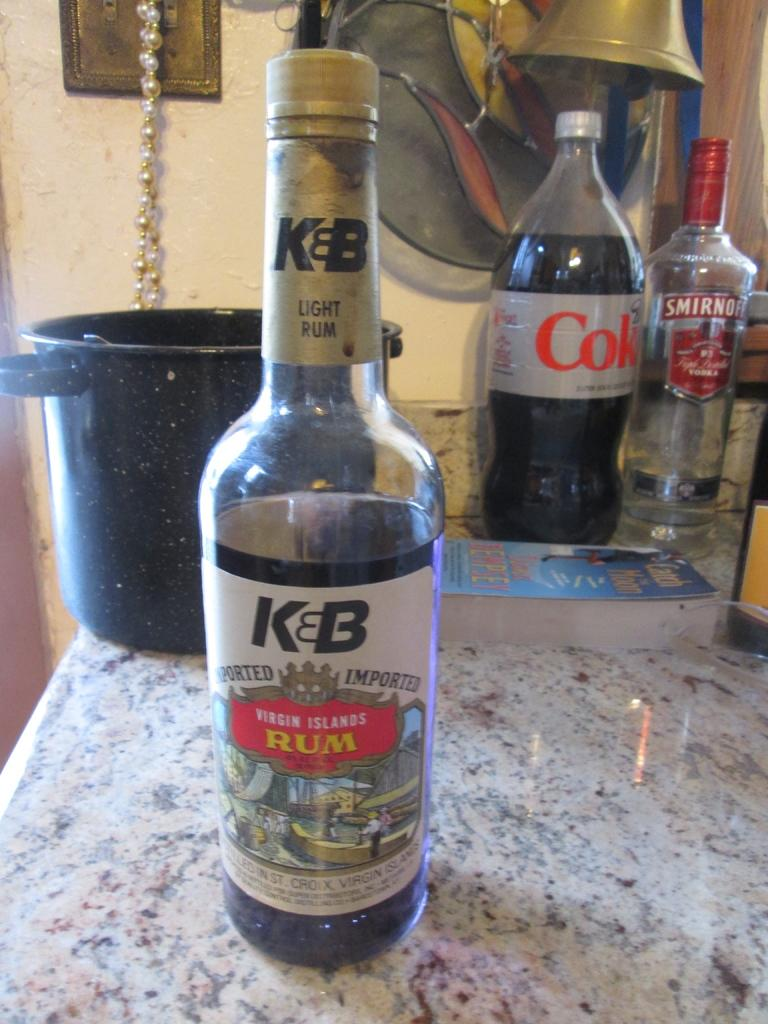What object can be seen in the image that typically contains a liquid? There is a bottle in the image that typically contains a liquid. What object can be seen in the image that is used for holding or reading information? There is a book in the image that is used for holding or reading information. What object can be seen in the image that helps us understand the context of the image? There is a bowl in the image, which could suggest that the image is related to food or a meal. What can be seen in the background of the image that provides context about the setting? There is a wall in the background of the image, which suggests that the image is taken indoors. Absurd Question/Answer: What type of flesh can be seen in the image? There is no flesh present in the image; it contains a bottle, a book, and a bowl. What type of station can be seen in the image? There is no station present in the image; it contains a bottle, a book, and a bowl. 